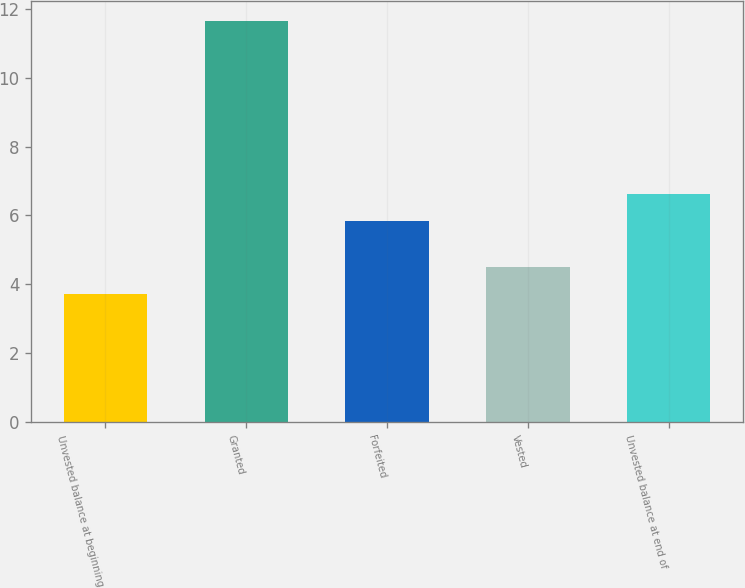Convert chart. <chart><loc_0><loc_0><loc_500><loc_500><bar_chart><fcel>Unvested balance at beginning<fcel>Granted<fcel>Forfeited<fcel>Vested<fcel>Unvested balance at end of<nl><fcel>3.73<fcel>11.63<fcel>5.83<fcel>4.52<fcel>6.62<nl></chart> 